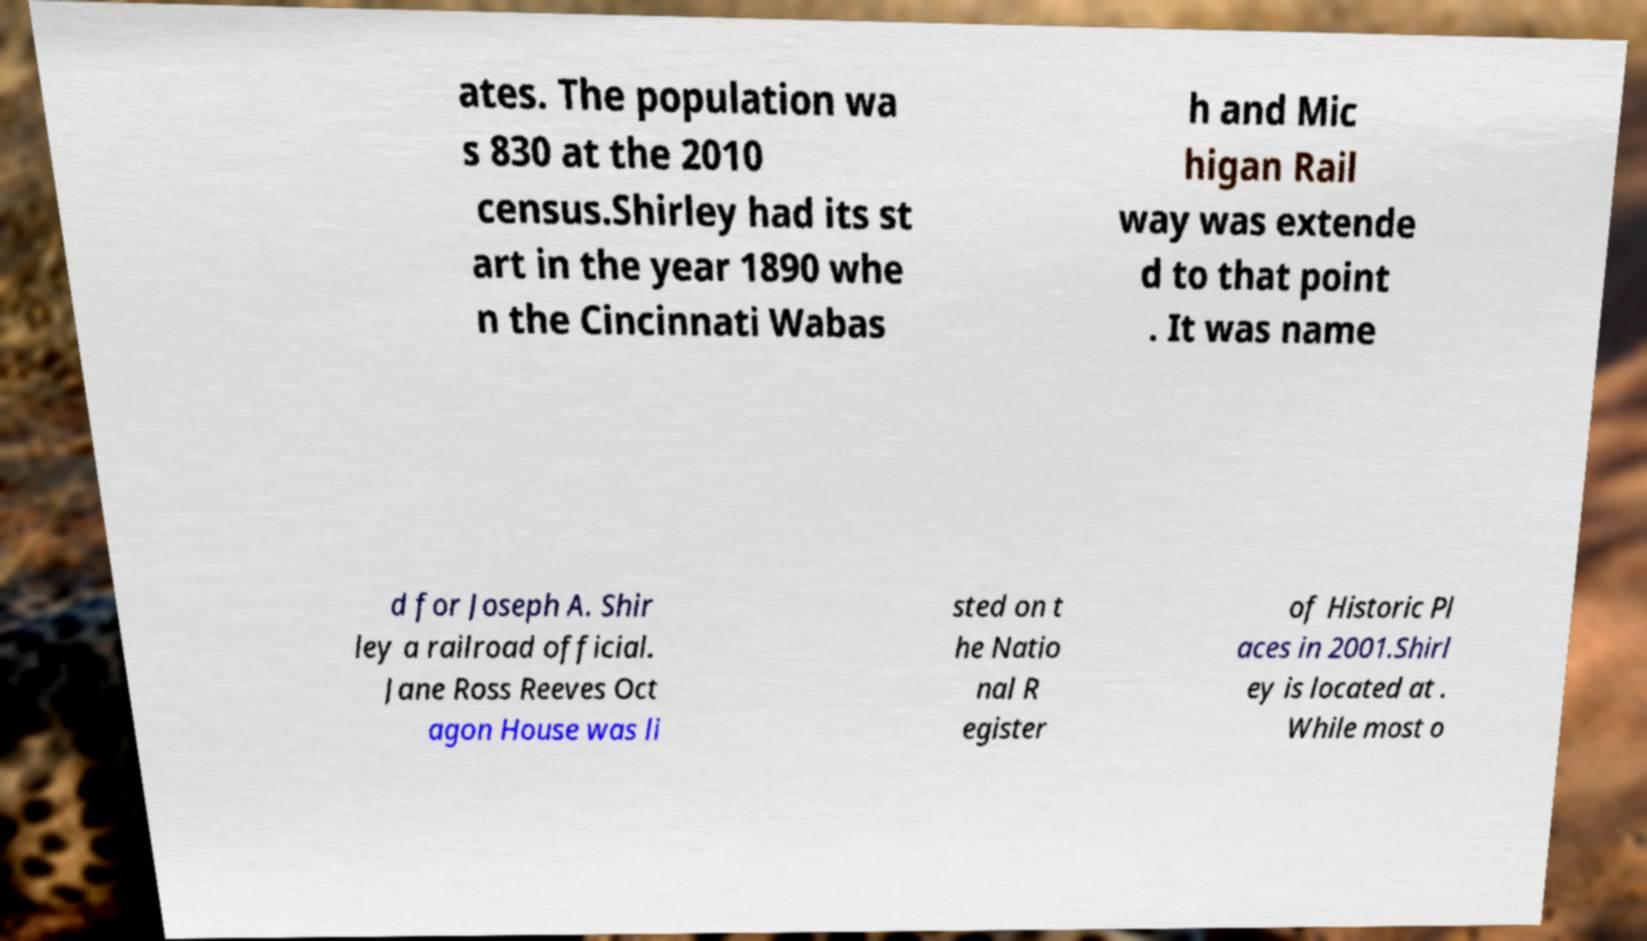Could you extract and type out the text from this image? ates. The population wa s 830 at the 2010 census.Shirley had its st art in the year 1890 whe n the Cincinnati Wabas h and Mic higan Rail way was extende d to that point . It was name d for Joseph A. Shir ley a railroad official. Jane Ross Reeves Oct agon House was li sted on t he Natio nal R egister of Historic Pl aces in 2001.Shirl ey is located at . While most o 